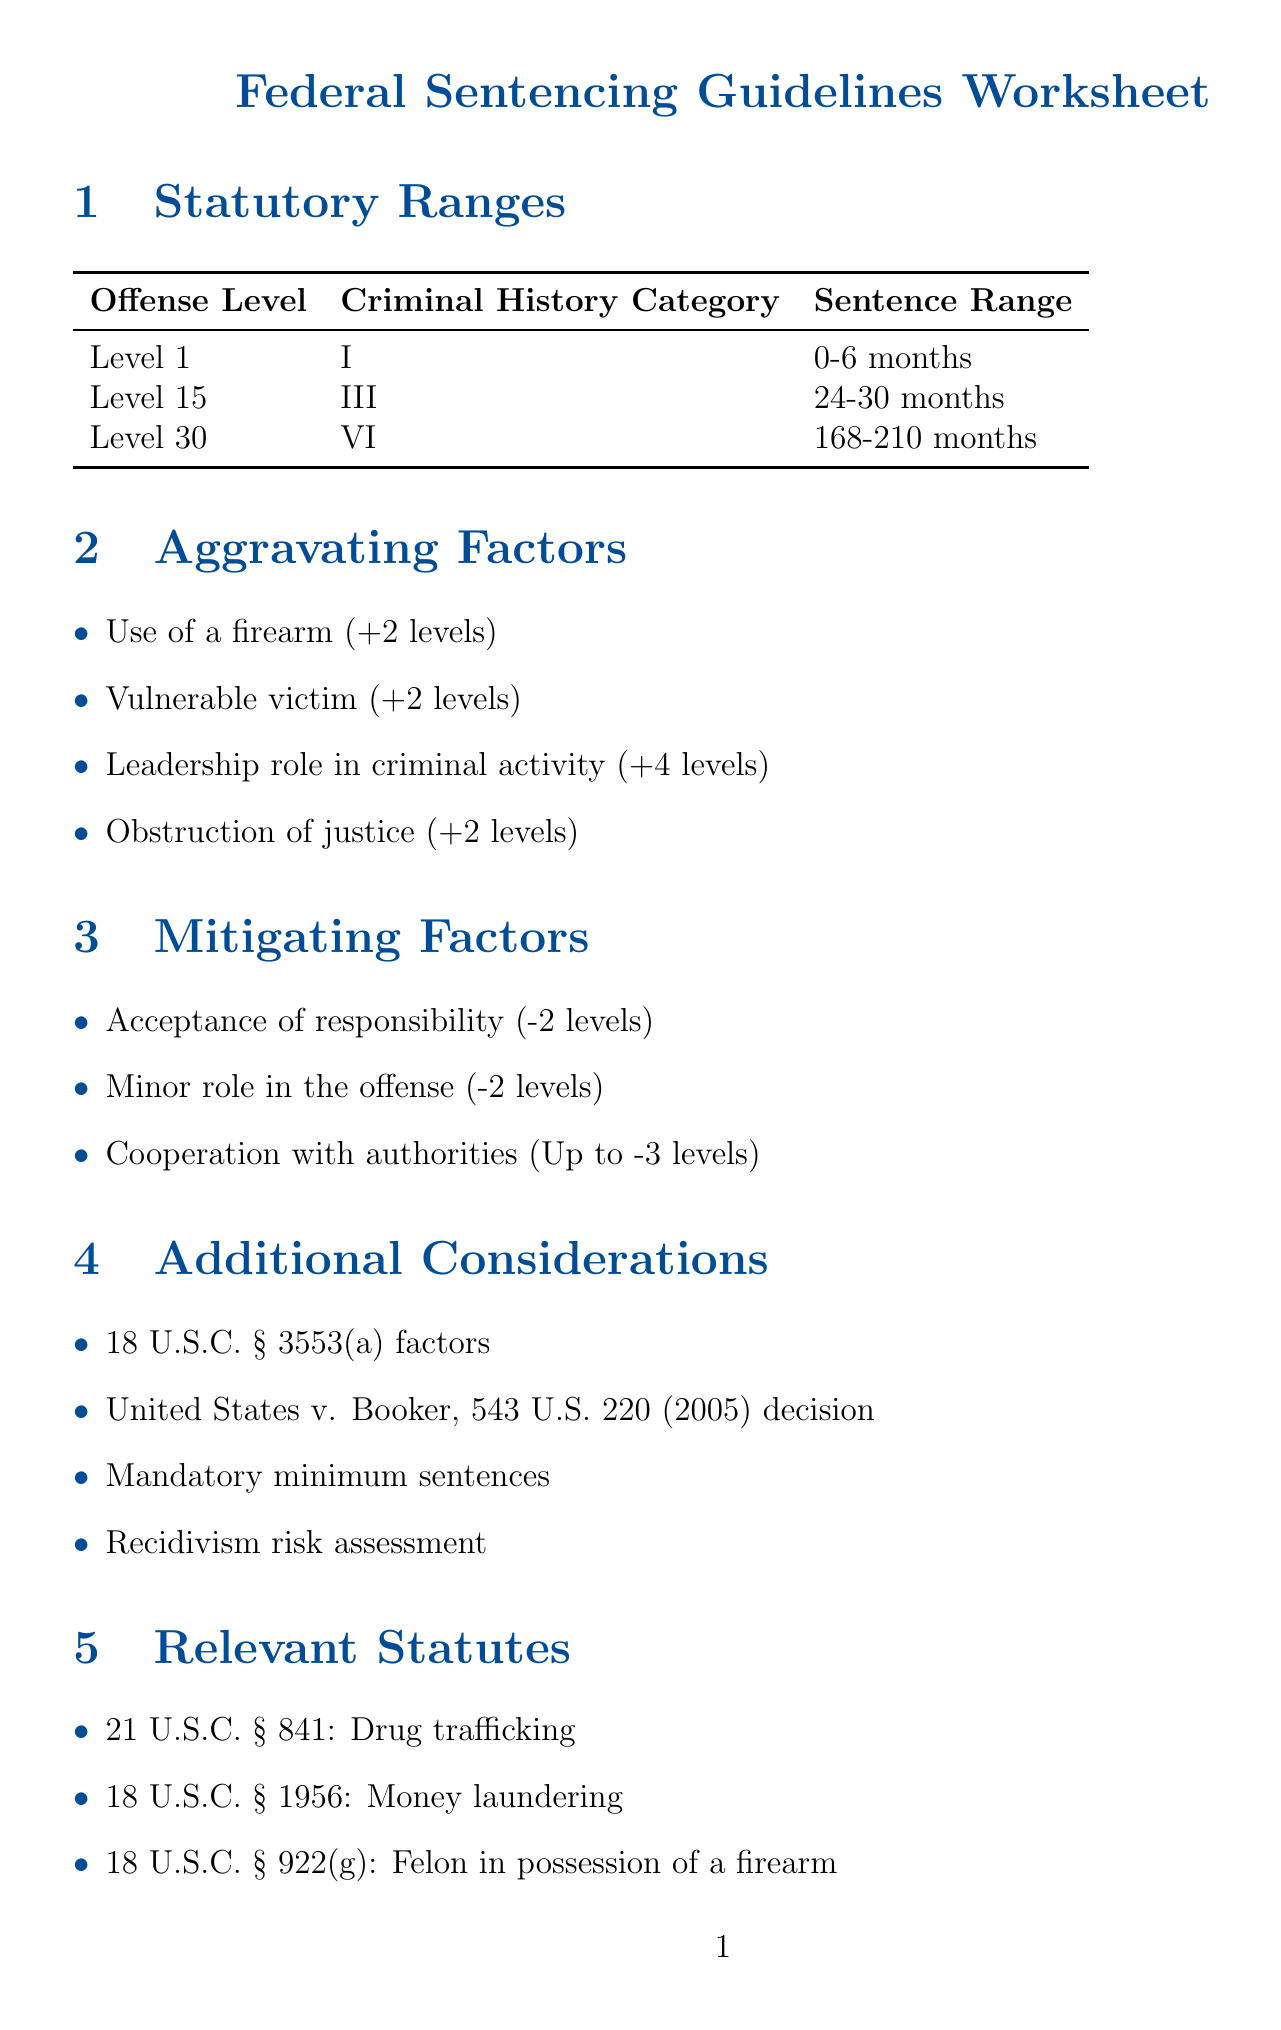What is the sentence range for Level 1, Criminal History Category I? The sentence range is listed in the statutory ranges section, specifically for Level 1 with Criminal History Category I.
Answer: 0-6 months How many levels does the aggravating factor "Use of a firearm" increase? The document specifies the increase in levels for each aggravating factor, indicating how they affect the sentence.
Answer: +2 levels What is the mitigating factor that leads to the greatest possible decrease in levels? The document lists mitigating factors and their corresponding decreases, allowing for identification of the most significant one.
Answer: Up to -3 levels What is the name of the case that discusses an upward departure based on criminal history? This information is derived from the case examples section, which provides relevant cases and their implications for sentencing.
Answer: United States v. Johnson How many statutory offenses are listed in the relevant statutes section? By reviewing the list in the relevant statutes section, the number of statutory offenses can be determined.
Answer: 3 Which section emphasizes adherence to guideline ranges? This question pertains to the core principles outlined in the document regarding the approach to sentencing.
Answer: Conservative Approach What is the statutory reference for drug trafficking? The relevant statutes section contains specific information linking statutory offenses to their legal references.
Answer: 21 U.S.C. § 841 What factor may lead to an increase of 4 levels in sentencing? The aggravating factors section specifies factors that could significantly increase the offense level.
Answer: Leadership role in criminal activity What factors are included in the additional considerations for sentencing? This question refers to the additional elements that may be factored into sentencing beyond the guidelines themselves.
Answer: 18 U.S.C. § 3553(a) factors, United States v. Booker, mandatory minimum sentences, recidivism risk assessment 